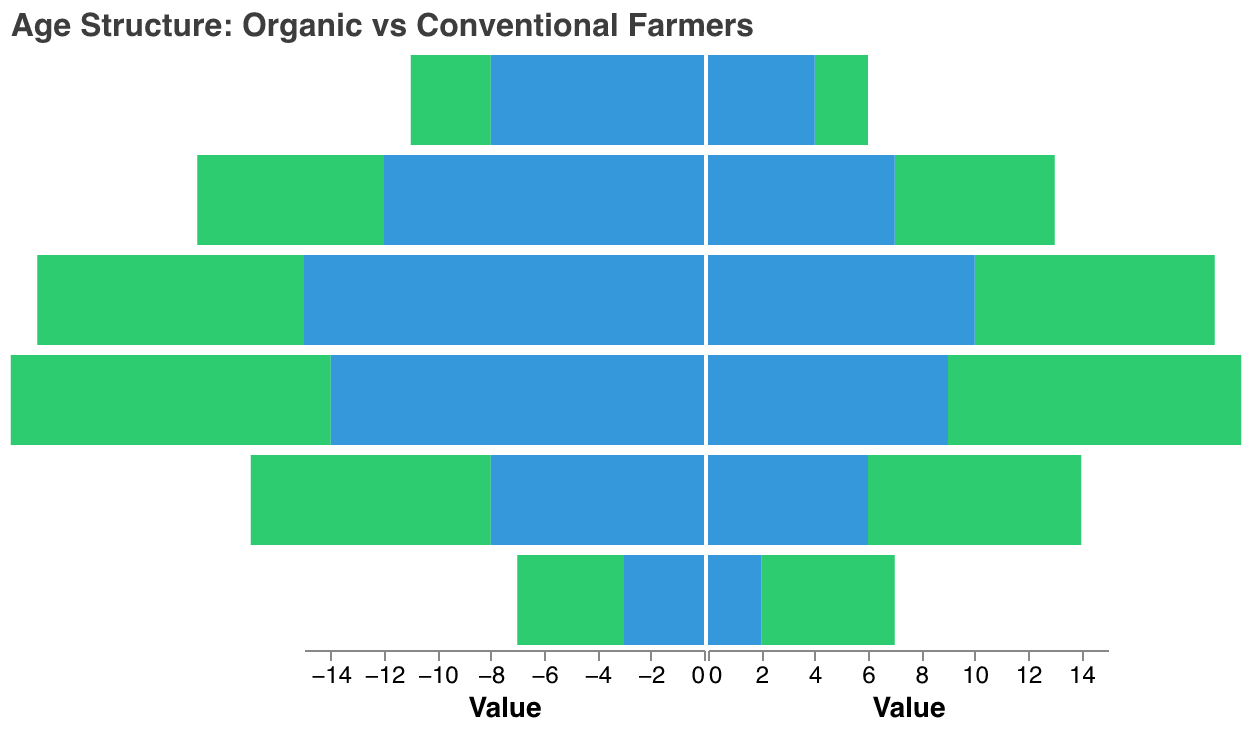What is the total number of organic females in the 35-44 age group? The figure shows 11 organic females in the 35-44 age group.
Answer: 11 Which age group has the highest number of organic male farmers? The 35-44 age group has the highest number of organic male farmers with 12.
Answer: 35-44 Compare the number of conventional male farmers to conventional female farmers in the 65+ age group. In the 65+ age group, there are 8 conventional male farmers and 4 conventional female farmers.
Answer: 8 vs 4 What is the difference in the number of organic males and conventional males in the 45-54 age group? There are 10 organic males and 15 conventional males in the 45-54 age group, so the difference is 15 - 10 = 5.
Answer: 5 How many more organic female farmers are there compared to conventional female farmers in the 35-44 age group? There are 11 organic female farmers and 9 conventional female farmers in the 35-44 age group, with a difference of 11 - 9 = 2.
Answer: 2 In which age group do we see the smallest number of conventional female farmers? The 18-24 age group has the smallest number of conventional female farmers, with 2 individuals.
Answer: 18-24 Is the number of conventional male farmers in the 55-64 age group greater than the combination of organic male and female farmers in the same age group? The number of conventional male farmers in the 55-64 age group is 12. The combined number of organic male and female farmers is 7 + 6 = 13. 12 is not greater than 13.
Answer: No What is the combined total of organic and conventional female farmers in the 25-34 age group? There are 8 organic females and 6 conventional females in the 25-34 age group, summing up to 8 + 6 = 14.
Answer: 14 Which category has a higher number of farmers in the 45-54 age group, organic male or conventional female? There are 10 organic males and 10 conventional females in the 45-54 age group, making them equal.
Answer: Equal 